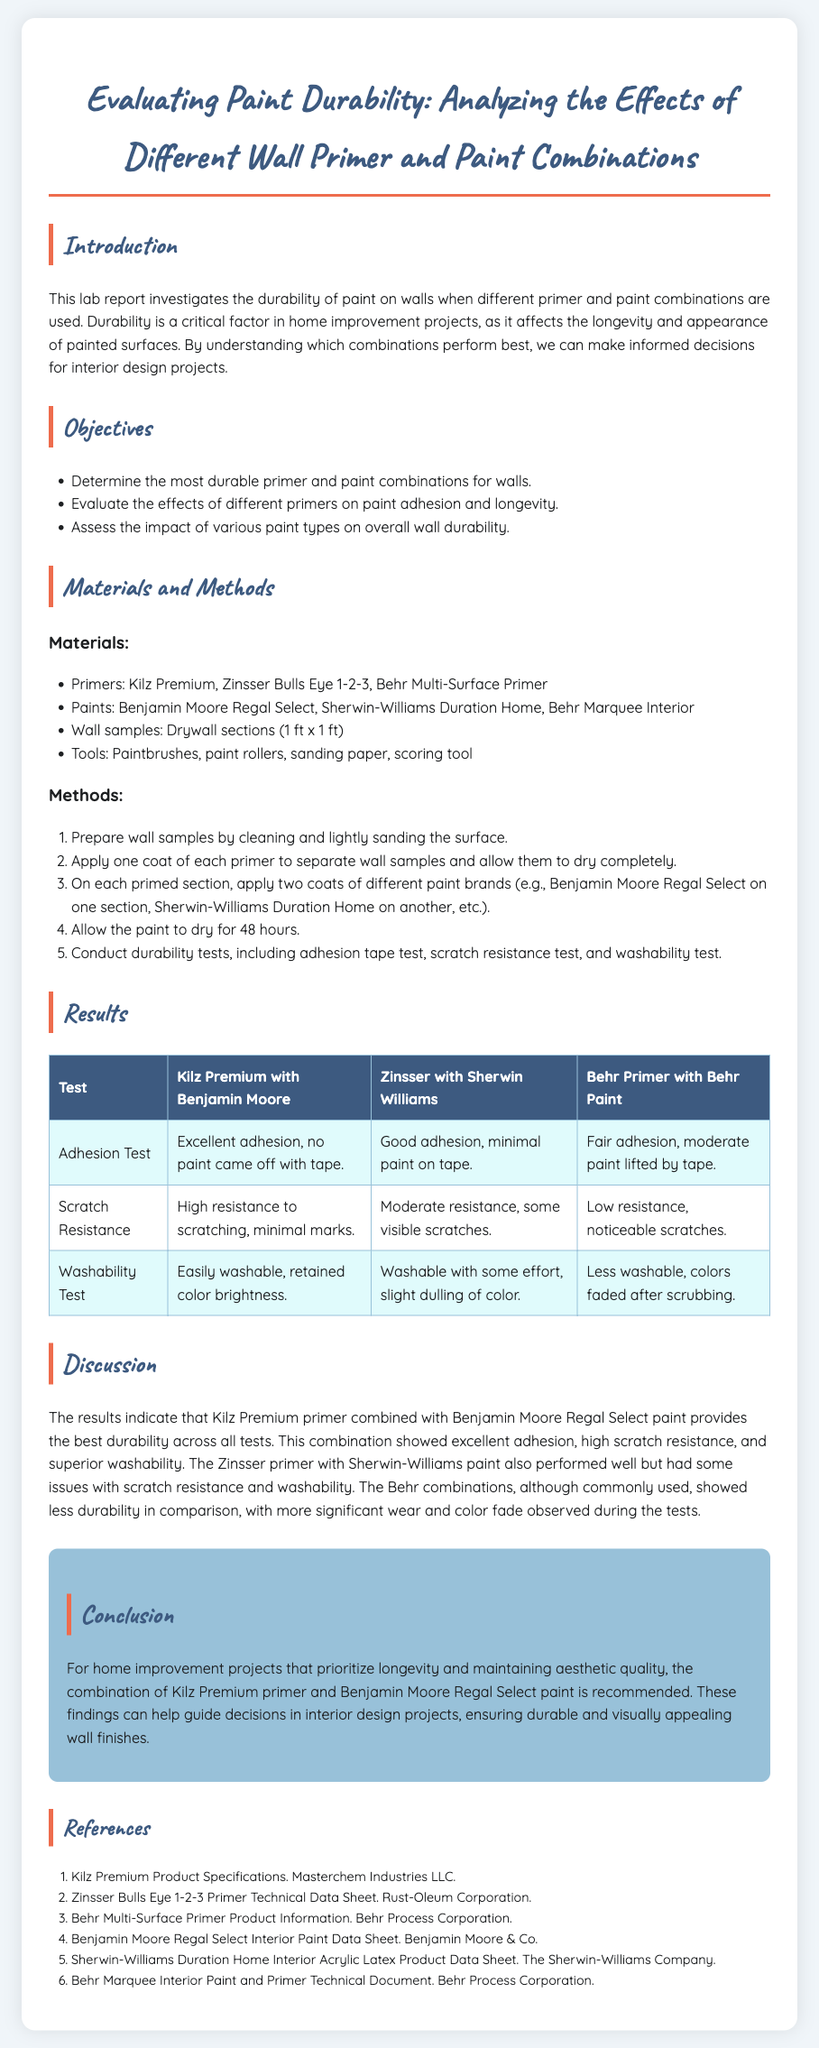What is the title of the lab report? The title is clearly stated at the top of the document, summarizing the main focus of the report.
Answer: Evaluating Paint Durability: Analyzing the Effects of Different Wall Primer and Paint Combinations What are the three primers used in the study? The report lists the primers used in the materials section, detailing what was tested.
Answer: Kilz Premium, Zinsser Bulls Eye 1-2-3, Behr Multi-Surface Primer Which paint combination showed the best adhesion in the tests? The results table highlights the performance of different combinations, revealing which one excelled in adhesion.
Answer: Kilz Premium with Benjamin Moore How many tests were conducted to evaluate durability? The methods section describes the tests that were performed to assess the paint durability, including adhesion, scratch resistance, and washability.
Answer: Three tests What was the conclusion about the Kilz Premium primer? The conclusion summarizes the findings related to the primer's performance in the context of durability and suitability for projects.
Answer: Recommended for durability Which primer and paint combination had moderate adhesion? The results table indicates the level of adhesion for each combination, specifically identifying the one with moderate performance.
Answer: Zinsser with Sherwin Williams In what section is the objective of the study stated? The objectives are detailed in a specific section designed to outline the aims of the research.
Answer: Objectives What type of wall samples were used in the experiments? The materials section describes the physical samples tested, providing specifications for what was used in the study.
Answer: Drywall sections 